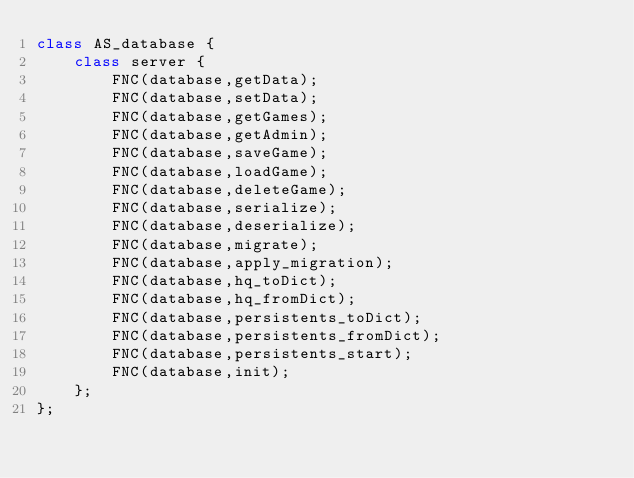Convert code to text. <code><loc_0><loc_0><loc_500><loc_500><_C++_>class AS_database {
    class server {
        FNC(database,getData);
        FNC(database,setData);
        FNC(database,getGames);
        FNC(database,getAdmin);
        FNC(database,saveGame);
        FNC(database,loadGame);
        FNC(database,deleteGame);
        FNC(database,serialize);
        FNC(database,deserialize);
        FNC(database,migrate);
        FNC(database,apply_migration);
        FNC(database,hq_toDict);
        FNC(database,hq_fromDict);
        FNC(database,persistents_toDict);
        FNC(database,persistents_fromDict);
        FNC(database,persistents_start);
        FNC(database,init);
    };
};
</code> 